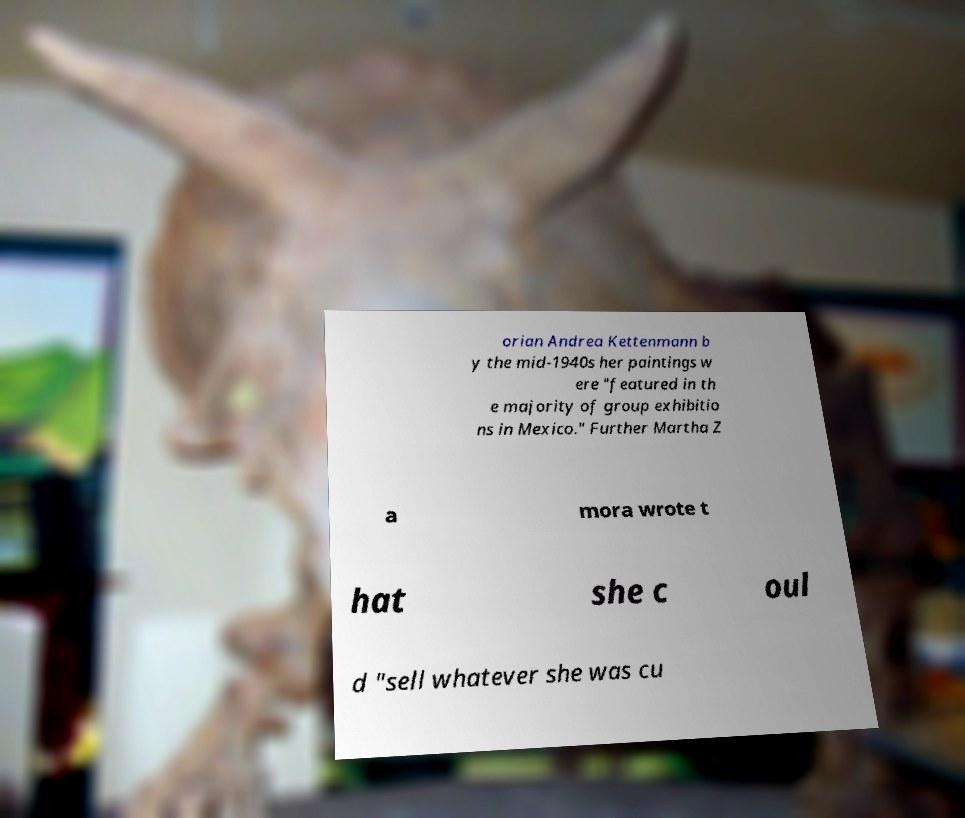What messages or text are displayed in this image? I need them in a readable, typed format. orian Andrea Kettenmann b y the mid-1940s her paintings w ere "featured in th e majority of group exhibitio ns in Mexico." Further Martha Z a mora wrote t hat she c oul d "sell whatever she was cu 